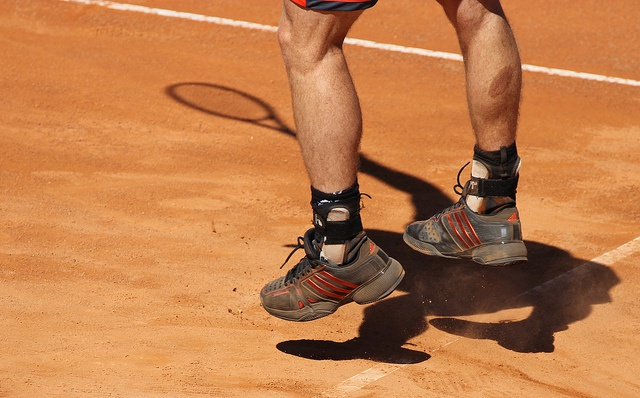Describe the objects in this image and their specific colors. I can see people in salmon, tan, black, and maroon tones and tennis racket in salmon, brown, red, and maroon tones in this image. 